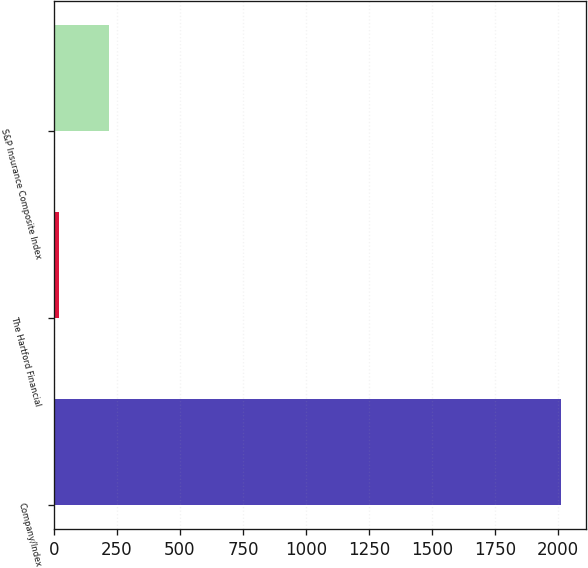Convert chart to OTSL. <chart><loc_0><loc_0><loc_500><loc_500><bar_chart><fcel>Company/Index<fcel>The Hartford Financial<fcel>S&P Insurance Composite Index<nl><fcel>2011<fcel>19.72<fcel>218.85<nl></chart> 